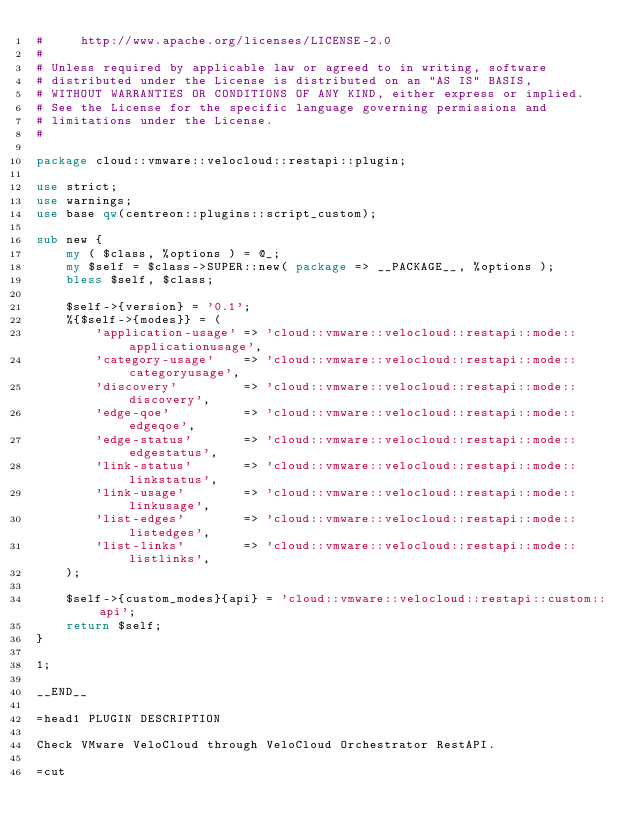Convert code to text. <code><loc_0><loc_0><loc_500><loc_500><_Perl_>#     http://www.apache.org/licenses/LICENSE-2.0
#
# Unless required by applicable law or agreed to in writing, software
# distributed under the License is distributed on an "AS IS" BASIS,
# WITHOUT WARRANTIES OR CONDITIONS OF ANY KIND, either express or implied.
# See the License for the specific language governing permissions and
# limitations under the License.
#

package cloud::vmware::velocloud::restapi::plugin;

use strict;
use warnings;
use base qw(centreon::plugins::script_custom);

sub new {
    my ( $class, %options ) = @_;
    my $self = $class->SUPER::new( package => __PACKAGE__, %options );
    bless $self, $class;

    $self->{version} = '0.1';
    %{$self->{modes}} = (
        'application-usage' => 'cloud::vmware::velocloud::restapi::mode::applicationusage',
        'category-usage'    => 'cloud::vmware::velocloud::restapi::mode::categoryusage',
        'discovery'         => 'cloud::vmware::velocloud::restapi::mode::discovery',
        'edge-qoe'          => 'cloud::vmware::velocloud::restapi::mode::edgeqoe',
        'edge-status'       => 'cloud::vmware::velocloud::restapi::mode::edgestatus',
        'link-status'       => 'cloud::vmware::velocloud::restapi::mode::linkstatus',
        'link-usage'        => 'cloud::vmware::velocloud::restapi::mode::linkusage',
        'list-edges'        => 'cloud::vmware::velocloud::restapi::mode::listedges',
        'list-links'        => 'cloud::vmware::velocloud::restapi::mode::listlinks',
    );

    $self->{custom_modes}{api} = 'cloud::vmware::velocloud::restapi::custom::api';
    return $self;
}

1;

__END__

=head1 PLUGIN DESCRIPTION

Check VMware VeloCloud through VeloCloud Orchestrator RestAPI.

=cut
</code> 